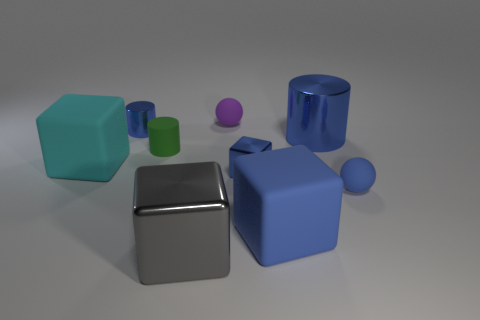There is a gray metallic cube; what number of large things are right of it?
Keep it short and to the point. 2. There is a small cylinder that is the same color as the tiny cube; what material is it?
Offer a very short reply. Metal. Are there any blue objects that have the same shape as the purple matte thing?
Provide a succinct answer. Yes. Is the material of the small ball in front of the tiny blue cylinder the same as the big blue thing that is in front of the big cyan thing?
Offer a very short reply. Yes. What is the size of the matte object that is on the right side of the large rubber block that is on the right side of the tiny blue thing to the left of the purple thing?
Your response must be concise. Small. There is a blue block that is the same size as the cyan object; what is its material?
Your response must be concise. Rubber. Is there a gray matte thing that has the same size as the purple matte sphere?
Your response must be concise. No. Is the big cyan rubber thing the same shape as the large gray object?
Your answer should be very brief. Yes. There is a tiny cylinder that is to the right of the blue metal cylinder that is left of the purple rubber ball; is there a rubber block that is right of it?
Provide a short and direct response. Yes. What number of other objects are the same color as the big cylinder?
Your response must be concise. 4. 